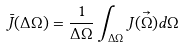Convert formula to latex. <formula><loc_0><loc_0><loc_500><loc_500>\bar { J } ( \Delta \Omega ) = \frac { 1 } { \Delta \Omega } \int _ { \Delta \Omega } J ( \vec { \Omega } ) d \Omega</formula> 